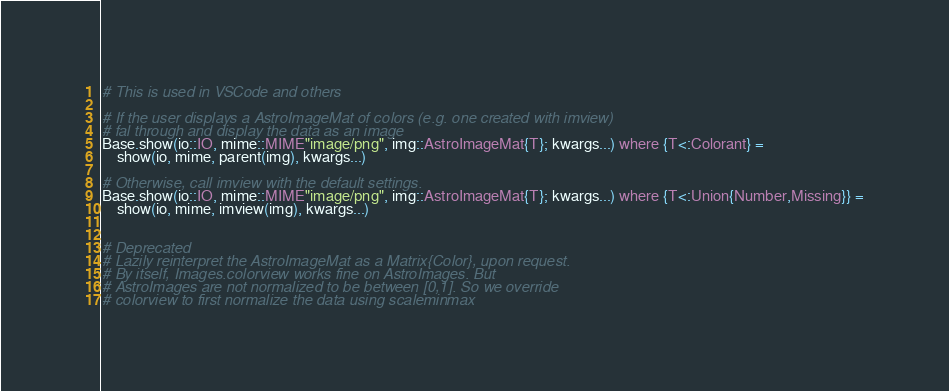<code> <loc_0><loc_0><loc_500><loc_500><_Julia_>
# This is used in VSCode and others

# If the user displays a AstroImageMat of colors (e.g. one created with imview)
# fal through and display the data as an image
Base.show(io::IO, mime::MIME"image/png", img::AstroImageMat{T}; kwargs...) where {T<:Colorant} =
    show(io, mime, parent(img), kwargs...)

# Otherwise, call imview with the default settings.
Base.show(io::IO, mime::MIME"image/png", img::AstroImageMat{T}; kwargs...) where {T<:Union{Number,Missing}} =
    show(io, mime, imview(img), kwargs...)


# Deprecated
# Lazily reinterpret the AstroImageMat as a Matrix{Color}, upon request.
# By itself, Images.colorview works fine on AstroImages. But 
# AstroImages are not normalized to be between [0,1]. So we override 
# colorview to first normalize the data using scaleminmax</code> 